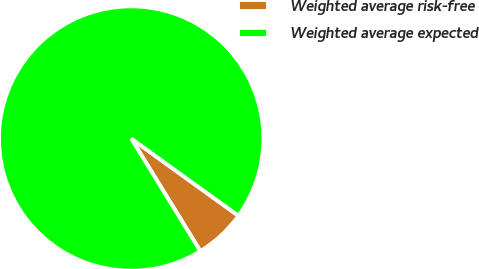Convert chart to OTSL. <chart><loc_0><loc_0><loc_500><loc_500><pie_chart><fcel>Weighted average risk-free<fcel>Weighted average expected<nl><fcel>6.3%<fcel>93.7%<nl></chart> 